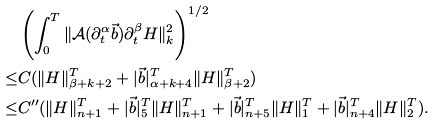Convert formula to latex. <formula><loc_0><loc_0><loc_500><loc_500>& \left ( \int _ { 0 } ^ { T } \| \mathcal { A } ( \partial _ { t } ^ { \alpha } \vec { b } ) \partial _ { t } ^ { \beta } H \| _ { k } ^ { 2 } \right ) ^ { 1 / 2 } \\ \leq & C ( \| H \| _ { \beta + k + 2 } ^ { T } + | \vec { b } | _ { \alpha + k + 4 } ^ { T } \| H \| _ { \beta + 2 } ^ { T } ) \\ \leq & C ^ { \prime \prime } ( \| H \| _ { n + 1 } ^ { T } + | \vec { b } | _ { 5 } ^ { T } \| H \| _ { n + 1 } ^ { T } + | \vec { b } | _ { n + 5 } ^ { T } \| H \| _ { 1 } ^ { T } + | \vec { b } | _ { n + 4 } ^ { T } \| H \| _ { 2 } ^ { T } ) .</formula> 